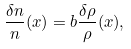Convert formula to latex. <formula><loc_0><loc_0><loc_500><loc_500>\frac { \delta n } { n } ( x ) = b \frac { \delta \rho } { \rho } ( x ) ,</formula> 